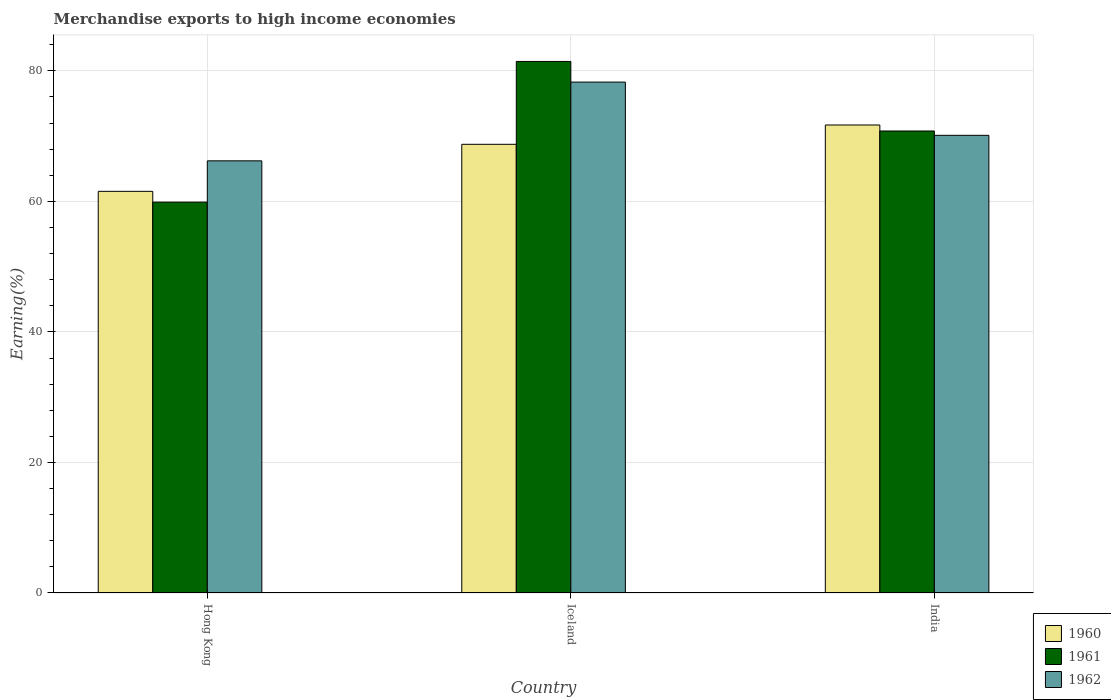How many different coloured bars are there?
Your answer should be very brief. 3. How many bars are there on the 2nd tick from the left?
Offer a very short reply. 3. In how many cases, is the number of bars for a given country not equal to the number of legend labels?
Your answer should be compact. 0. What is the percentage of amount earned from merchandise exports in 1960 in Hong Kong?
Make the answer very short. 61.54. Across all countries, what is the maximum percentage of amount earned from merchandise exports in 1962?
Offer a terse response. 78.28. Across all countries, what is the minimum percentage of amount earned from merchandise exports in 1962?
Keep it short and to the point. 66.22. In which country was the percentage of amount earned from merchandise exports in 1962 maximum?
Offer a very short reply. Iceland. In which country was the percentage of amount earned from merchandise exports in 1960 minimum?
Provide a succinct answer. Hong Kong. What is the total percentage of amount earned from merchandise exports in 1962 in the graph?
Ensure brevity in your answer.  214.62. What is the difference between the percentage of amount earned from merchandise exports in 1960 in Hong Kong and that in Iceland?
Offer a terse response. -7.21. What is the difference between the percentage of amount earned from merchandise exports in 1962 in Iceland and the percentage of amount earned from merchandise exports in 1961 in Hong Kong?
Offer a very short reply. 18.39. What is the average percentage of amount earned from merchandise exports in 1962 per country?
Provide a succinct answer. 71.54. What is the difference between the percentage of amount earned from merchandise exports of/in 1960 and percentage of amount earned from merchandise exports of/in 1962 in Iceland?
Provide a short and direct response. -9.53. In how many countries, is the percentage of amount earned from merchandise exports in 1962 greater than 28 %?
Provide a short and direct response. 3. What is the ratio of the percentage of amount earned from merchandise exports in 1961 in Iceland to that in India?
Make the answer very short. 1.15. What is the difference between the highest and the second highest percentage of amount earned from merchandise exports in 1961?
Your answer should be compact. 21.55. What is the difference between the highest and the lowest percentage of amount earned from merchandise exports in 1960?
Offer a terse response. 10.17. In how many countries, is the percentage of amount earned from merchandise exports in 1961 greater than the average percentage of amount earned from merchandise exports in 1961 taken over all countries?
Offer a terse response. 2. Is it the case that in every country, the sum of the percentage of amount earned from merchandise exports in 1962 and percentage of amount earned from merchandise exports in 1960 is greater than the percentage of amount earned from merchandise exports in 1961?
Your answer should be very brief. Yes. How many bars are there?
Your answer should be very brief. 9. How many countries are there in the graph?
Offer a very short reply. 3. Are the values on the major ticks of Y-axis written in scientific E-notation?
Offer a terse response. No. Does the graph contain grids?
Offer a very short reply. Yes. How many legend labels are there?
Keep it short and to the point. 3. How are the legend labels stacked?
Your answer should be very brief. Vertical. What is the title of the graph?
Give a very brief answer. Merchandise exports to high income economies. Does "1987" appear as one of the legend labels in the graph?
Keep it short and to the point. No. What is the label or title of the X-axis?
Provide a succinct answer. Country. What is the label or title of the Y-axis?
Provide a short and direct response. Earning(%). What is the Earning(%) of 1960 in Hong Kong?
Provide a short and direct response. 61.54. What is the Earning(%) of 1961 in Hong Kong?
Your response must be concise. 59.89. What is the Earning(%) of 1962 in Hong Kong?
Your answer should be compact. 66.22. What is the Earning(%) in 1960 in Iceland?
Keep it short and to the point. 68.75. What is the Earning(%) in 1961 in Iceland?
Offer a very short reply. 81.44. What is the Earning(%) of 1962 in Iceland?
Offer a very short reply. 78.28. What is the Earning(%) in 1960 in India?
Offer a very short reply. 71.71. What is the Earning(%) in 1961 in India?
Your answer should be compact. 70.79. What is the Earning(%) of 1962 in India?
Offer a terse response. 70.13. Across all countries, what is the maximum Earning(%) of 1960?
Provide a short and direct response. 71.71. Across all countries, what is the maximum Earning(%) in 1961?
Give a very brief answer. 81.44. Across all countries, what is the maximum Earning(%) of 1962?
Your response must be concise. 78.28. Across all countries, what is the minimum Earning(%) in 1960?
Offer a very short reply. 61.54. Across all countries, what is the minimum Earning(%) of 1961?
Your answer should be very brief. 59.89. Across all countries, what is the minimum Earning(%) in 1962?
Offer a terse response. 66.22. What is the total Earning(%) of 1960 in the graph?
Offer a very short reply. 202. What is the total Earning(%) of 1961 in the graph?
Offer a terse response. 212.13. What is the total Earning(%) of 1962 in the graph?
Make the answer very short. 214.62. What is the difference between the Earning(%) in 1960 in Hong Kong and that in Iceland?
Your answer should be compact. -7.21. What is the difference between the Earning(%) of 1961 in Hong Kong and that in Iceland?
Your response must be concise. -21.55. What is the difference between the Earning(%) of 1962 in Hong Kong and that in Iceland?
Your answer should be compact. -12.07. What is the difference between the Earning(%) of 1960 in Hong Kong and that in India?
Provide a succinct answer. -10.17. What is the difference between the Earning(%) in 1961 in Hong Kong and that in India?
Offer a terse response. -10.9. What is the difference between the Earning(%) of 1962 in Hong Kong and that in India?
Provide a short and direct response. -3.91. What is the difference between the Earning(%) of 1960 in Iceland and that in India?
Provide a succinct answer. -2.96. What is the difference between the Earning(%) of 1961 in Iceland and that in India?
Offer a very short reply. 10.65. What is the difference between the Earning(%) in 1962 in Iceland and that in India?
Keep it short and to the point. 8.16. What is the difference between the Earning(%) of 1960 in Hong Kong and the Earning(%) of 1961 in Iceland?
Your answer should be very brief. -19.9. What is the difference between the Earning(%) in 1960 in Hong Kong and the Earning(%) in 1962 in Iceland?
Offer a terse response. -16.74. What is the difference between the Earning(%) of 1961 in Hong Kong and the Earning(%) of 1962 in Iceland?
Make the answer very short. -18.39. What is the difference between the Earning(%) of 1960 in Hong Kong and the Earning(%) of 1961 in India?
Your response must be concise. -9.25. What is the difference between the Earning(%) of 1960 in Hong Kong and the Earning(%) of 1962 in India?
Give a very brief answer. -8.58. What is the difference between the Earning(%) in 1961 in Hong Kong and the Earning(%) in 1962 in India?
Give a very brief answer. -10.23. What is the difference between the Earning(%) of 1960 in Iceland and the Earning(%) of 1961 in India?
Make the answer very short. -2.04. What is the difference between the Earning(%) in 1960 in Iceland and the Earning(%) in 1962 in India?
Provide a short and direct response. -1.38. What is the difference between the Earning(%) of 1961 in Iceland and the Earning(%) of 1962 in India?
Your answer should be very brief. 11.32. What is the average Earning(%) in 1960 per country?
Give a very brief answer. 67.33. What is the average Earning(%) in 1961 per country?
Your response must be concise. 70.71. What is the average Earning(%) of 1962 per country?
Your answer should be compact. 71.54. What is the difference between the Earning(%) of 1960 and Earning(%) of 1961 in Hong Kong?
Your answer should be compact. 1.65. What is the difference between the Earning(%) in 1960 and Earning(%) in 1962 in Hong Kong?
Your response must be concise. -4.67. What is the difference between the Earning(%) of 1961 and Earning(%) of 1962 in Hong Kong?
Your answer should be compact. -6.32. What is the difference between the Earning(%) of 1960 and Earning(%) of 1961 in Iceland?
Offer a terse response. -12.69. What is the difference between the Earning(%) in 1960 and Earning(%) in 1962 in Iceland?
Ensure brevity in your answer.  -9.53. What is the difference between the Earning(%) in 1961 and Earning(%) in 1962 in Iceland?
Your answer should be very brief. 3.16. What is the difference between the Earning(%) in 1960 and Earning(%) in 1961 in India?
Offer a very short reply. 0.92. What is the difference between the Earning(%) of 1960 and Earning(%) of 1962 in India?
Provide a short and direct response. 1.58. What is the difference between the Earning(%) of 1961 and Earning(%) of 1962 in India?
Ensure brevity in your answer.  0.66. What is the ratio of the Earning(%) of 1960 in Hong Kong to that in Iceland?
Your response must be concise. 0.9. What is the ratio of the Earning(%) in 1961 in Hong Kong to that in Iceland?
Ensure brevity in your answer.  0.74. What is the ratio of the Earning(%) of 1962 in Hong Kong to that in Iceland?
Provide a short and direct response. 0.85. What is the ratio of the Earning(%) of 1960 in Hong Kong to that in India?
Offer a very short reply. 0.86. What is the ratio of the Earning(%) of 1961 in Hong Kong to that in India?
Offer a terse response. 0.85. What is the ratio of the Earning(%) of 1962 in Hong Kong to that in India?
Offer a terse response. 0.94. What is the ratio of the Earning(%) of 1960 in Iceland to that in India?
Offer a very short reply. 0.96. What is the ratio of the Earning(%) in 1961 in Iceland to that in India?
Provide a short and direct response. 1.15. What is the ratio of the Earning(%) of 1962 in Iceland to that in India?
Offer a very short reply. 1.12. What is the difference between the highest and the second highest Earning(%) in 1960?
Make the answer very short. 2.96. What is the difference between the highest and the second highest Earning(%) in 1961?
Your answer should be very brief. 10.65. What is the difference between the highest and the second highest Earning(%) of 1962?
Give a very brief answer. 8.16. What is the difference between the highest and the lowest Earning(%) of 1960?
Provide a succinct answer. 10.17. What is the difference between the highest and the lowest Earning(%) of 1961?
Ensure brevity in your answer.  21.55. What is the difference between the highest and the lowest Earning(%) in 1962?
Offer a very short reply. 12.07. 